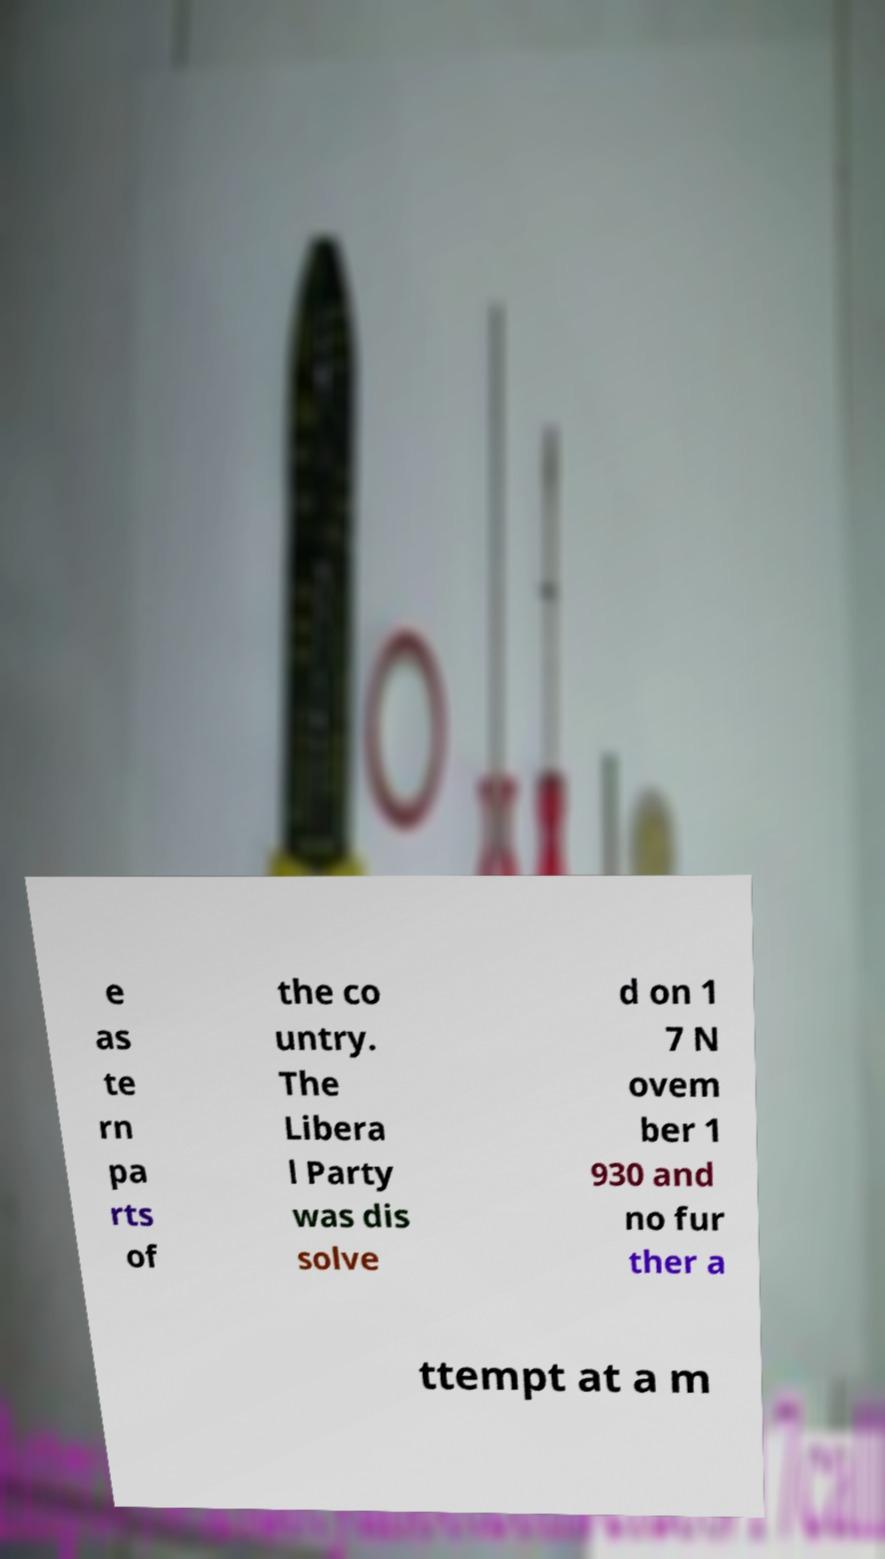Can you read and provide the text displayed in the image?This photo seems to have some interesting text. Can you extract and type it out for me? e as te rn pa rts of the co untry. The Libera l Party was dis solve d on 1 7 N ovem ber 1 930 and no fur ther a ttempt at a m 